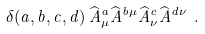Convert formula to latex. <formula><loc_0><loc_0><loc_500><loc_500>\delta ( a , b , c , d ) \, \widehat { A } ^ { a } _ { \mu } \widehat { A } ^ { b \mu } \widehat { A } ^ { c } _ { \nu } \widehat { A } ^ { d \nu } \ .</formula> 